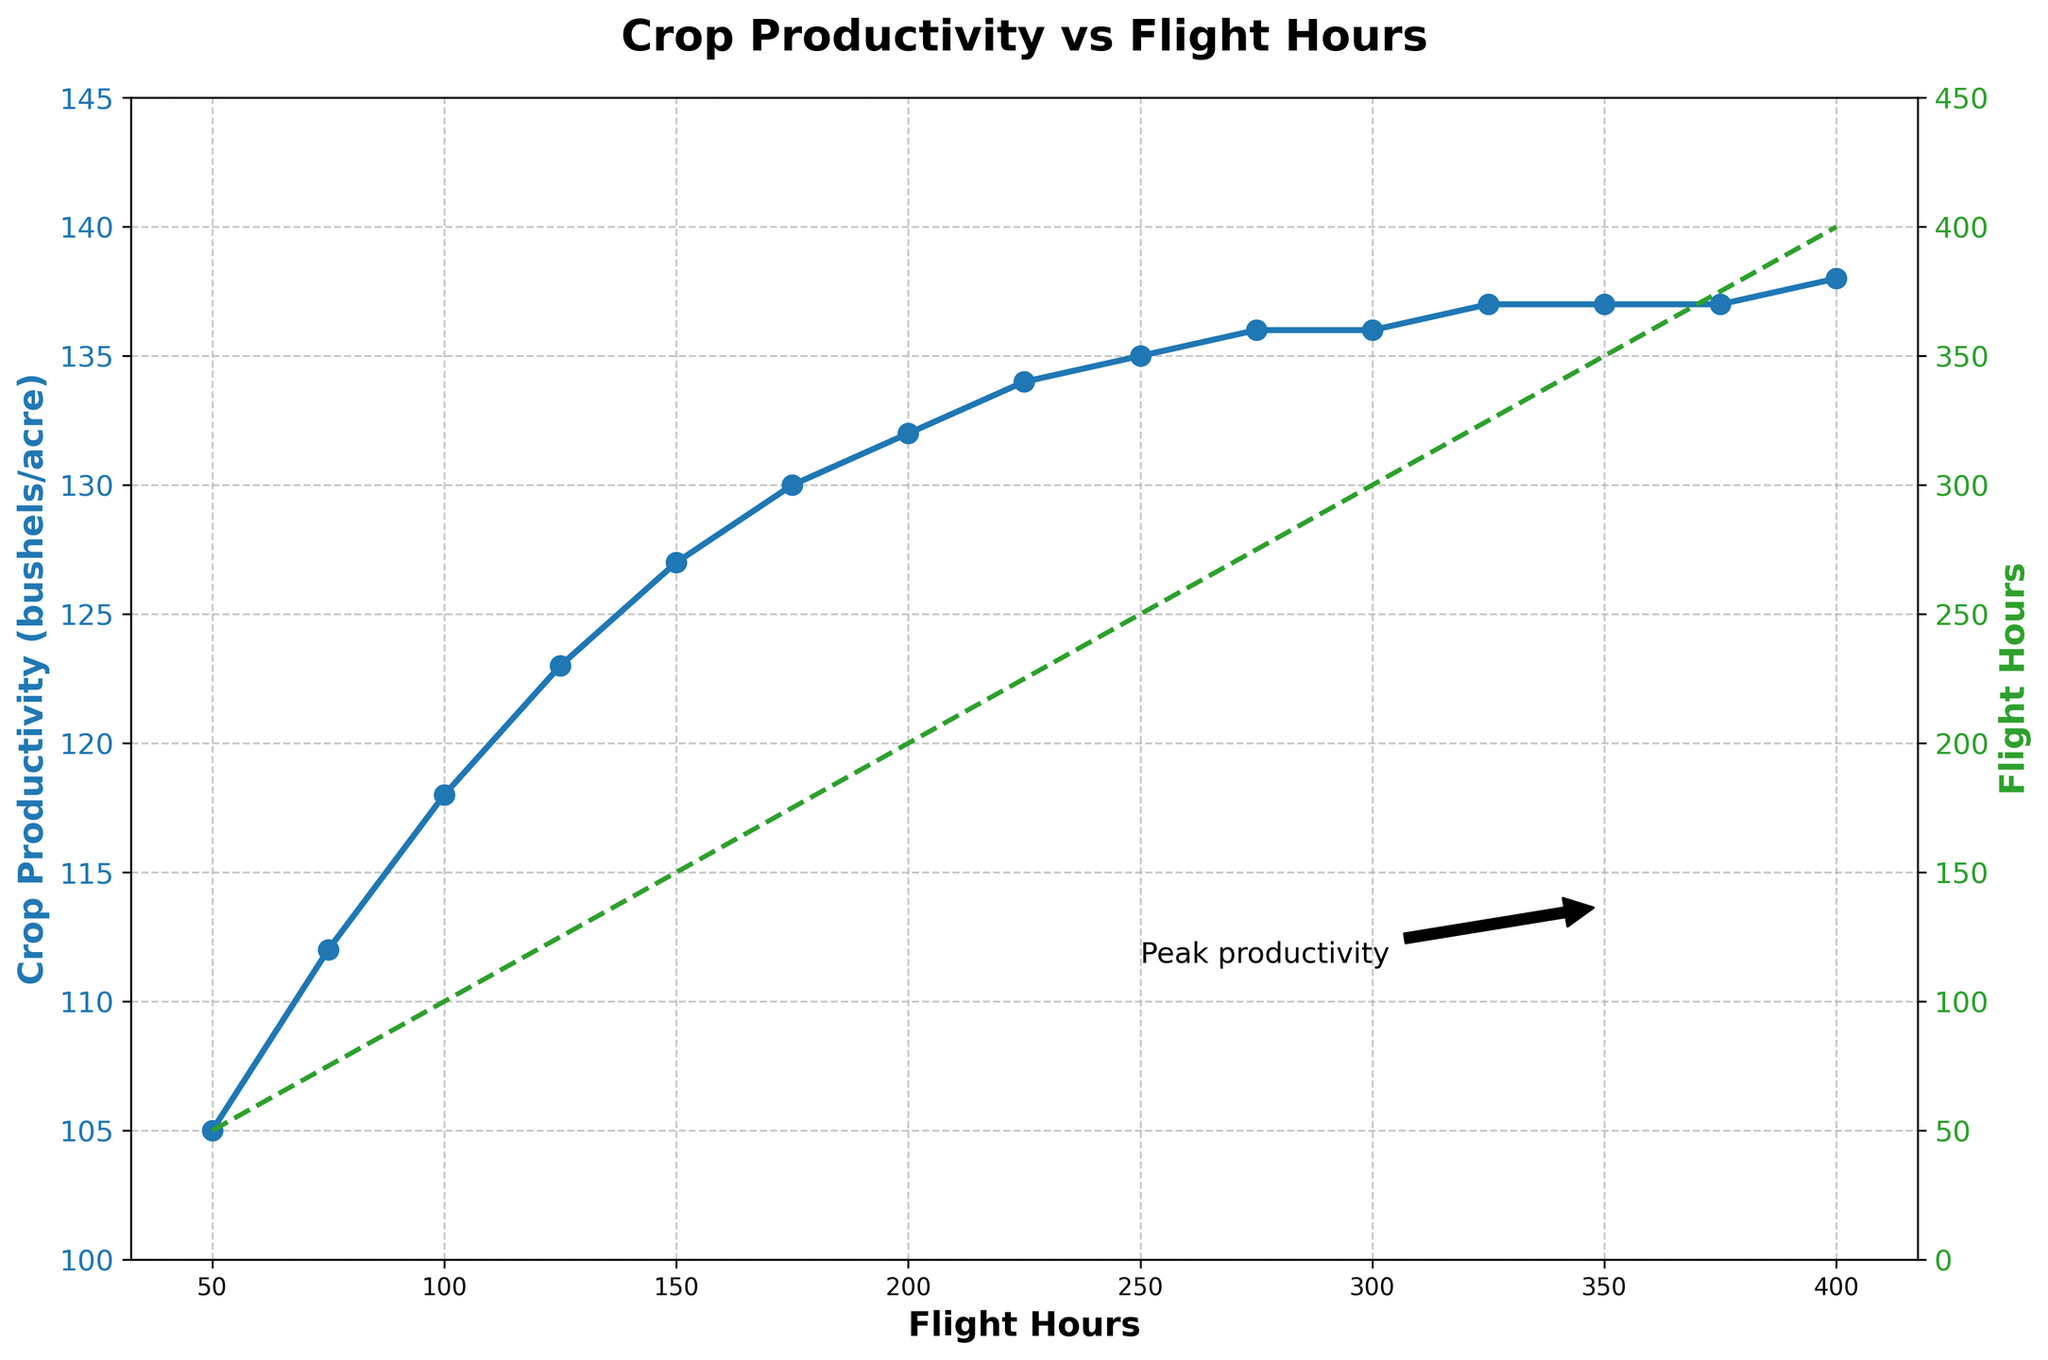What is the crop productivity at 200 flight hours? Locate the data point where Flight Hours is 200 and read the corresponding Crop Productivity value from the plot.
Answer: 132 bushels/acre How much does crop productivity increase from 100 to 200 flight hours? Identify the Crop Productivity values at 100 and 200 flight hours, which are 118 and 132 bushels/acre respectively, then subtract the first value from the second. (132 - 118)
Answer: 14 bushels/acre At what flight hours does crop productivity reach its peak in the plot? Look for the highest point on the Crop Productivity line, the peak value is indicated near 350 and 375 flight hours.
Answer: 375 flight hours Is there any flight hour when both the lines (Flight Hours and Crop Productivity) intersect? Observing the plot, the Crop Productivity line never intersects with the Flight Hours line.
Answer: No What is the approximate increase in crop productivity between 50 flight hours and 400 flight hours? Locate the Crop Productivity values at 50 and 400 flight hours, which are 105 and 138 bushels/acre respectively. Subtract the first value from the second. (138 - 105)
Answer: 33 bushels/acre What is the difference in crop productivity between 300 and 350 flight hours? Find the Crop Productivity at 300 and 350 flight hours, which are 136 and 137 bushels/acre respectively. Subtract the first value from the second. (137 - 136)
Answer: 1 bushel/acre What does the dashed green line represent in the plot? The plot shows that the dashed green line follows the Flight Hours values on both the axes. Therefore, it represents the Flight Hours on the secondary y-axis.
Answer: Flight Hours How many flight hours are required to reach a crop productivity of 130 bushels/acre? Locate the data point where Crop Productivity is 130 bushels/acre and read the corresponding Flight Hours value from the plot.
Answer: 175 flight hours 